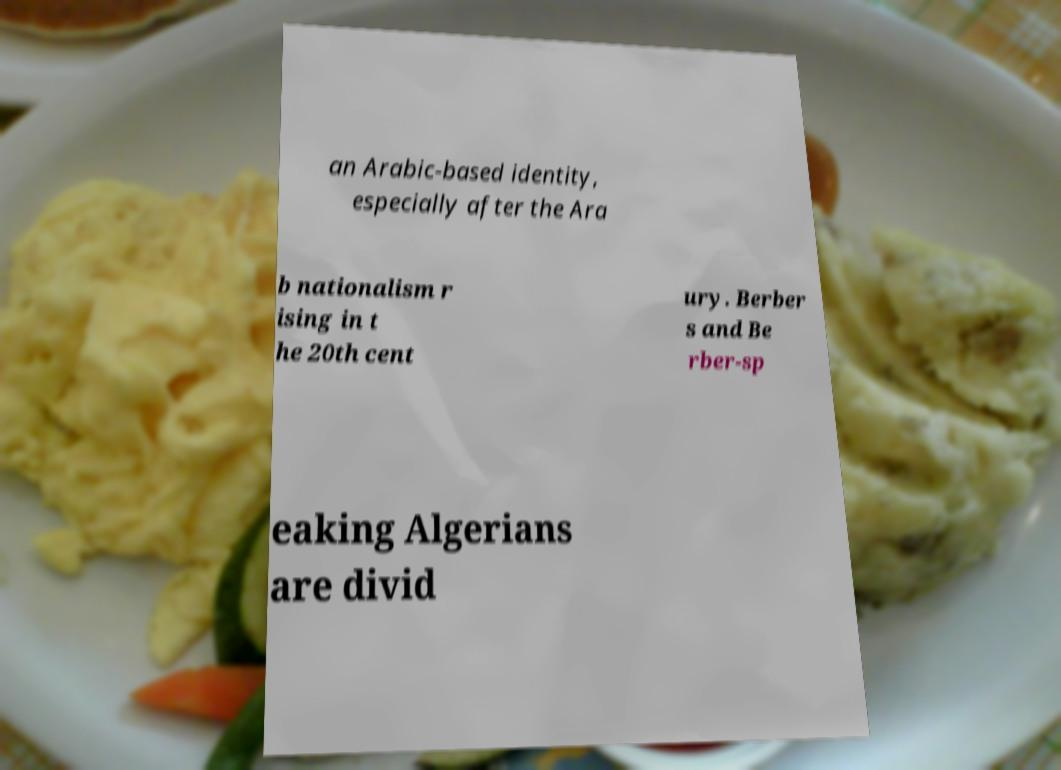What messages or text are displayed in this image? I need them in a readable, typed format. an Arabic-based identity, especially after the Ara b nationalism r ising in t he 20th cent ury. Berber s and Be rber-sp eaking Algerians are divid 